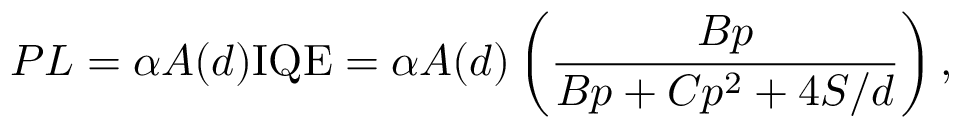<formula> <loc_0><loc_0><loc_500><loc_500>P L = \alpha A ( d ) { I Q E } = \alpha A ( d ) \left ( \frac { B p } { B p + C p ^ { 2 } + 4 S / d } \right ) ,</formula> 